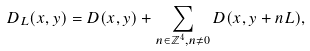Convert formula to latex. <formula><loc_0><loc_0><loc_500><loc_500>D _ { L } ( x , y ) = D ( x , y ) + \sum _ { n \in \mathbb { Z } ^ { 4 } , n \not = 0 } D ( x , y + n L ) ,</formula> 